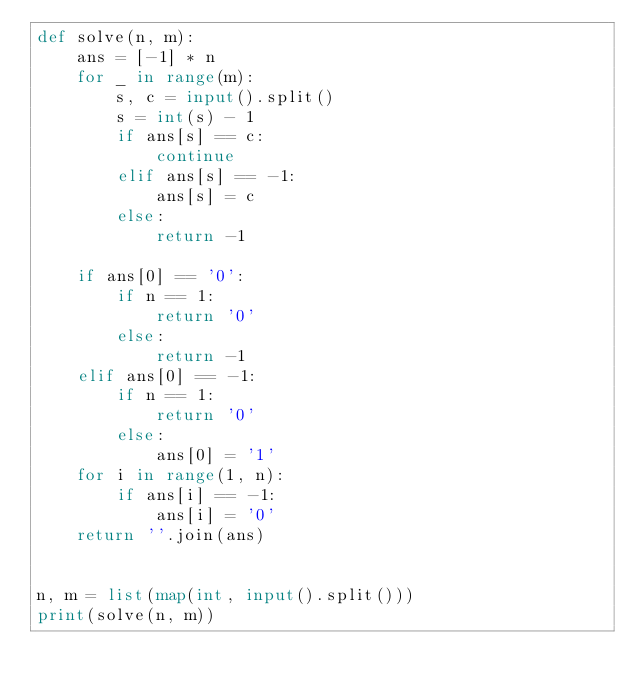Convert code to text. <code><loc_0><loc_0><loc_500><loc_500><_Python_>def solve(n, m):
    ans = [-1] * n
    for _ in range(m):
        s, c = input().split()
        s = int(s) - 1
        if ans[s] == c:
            continue
        elif ans[s] == -1:
            ans[s] = c
        else:
            return -1
 
    if ans[0] == '0':
        if n == 1:
            return '0'
        else:
            return -1
    elif ans[0] == -1:
        if n == 1:
            return '0'
        else:
            ans[0] = '1'
    for i in range(1, n):
        if ans[i] == -1:
            ans[i] = '0'
    return ''.join(ans)
 
 
n, m = list(map(int, input().split()))
print(solve(n, m))</code> 